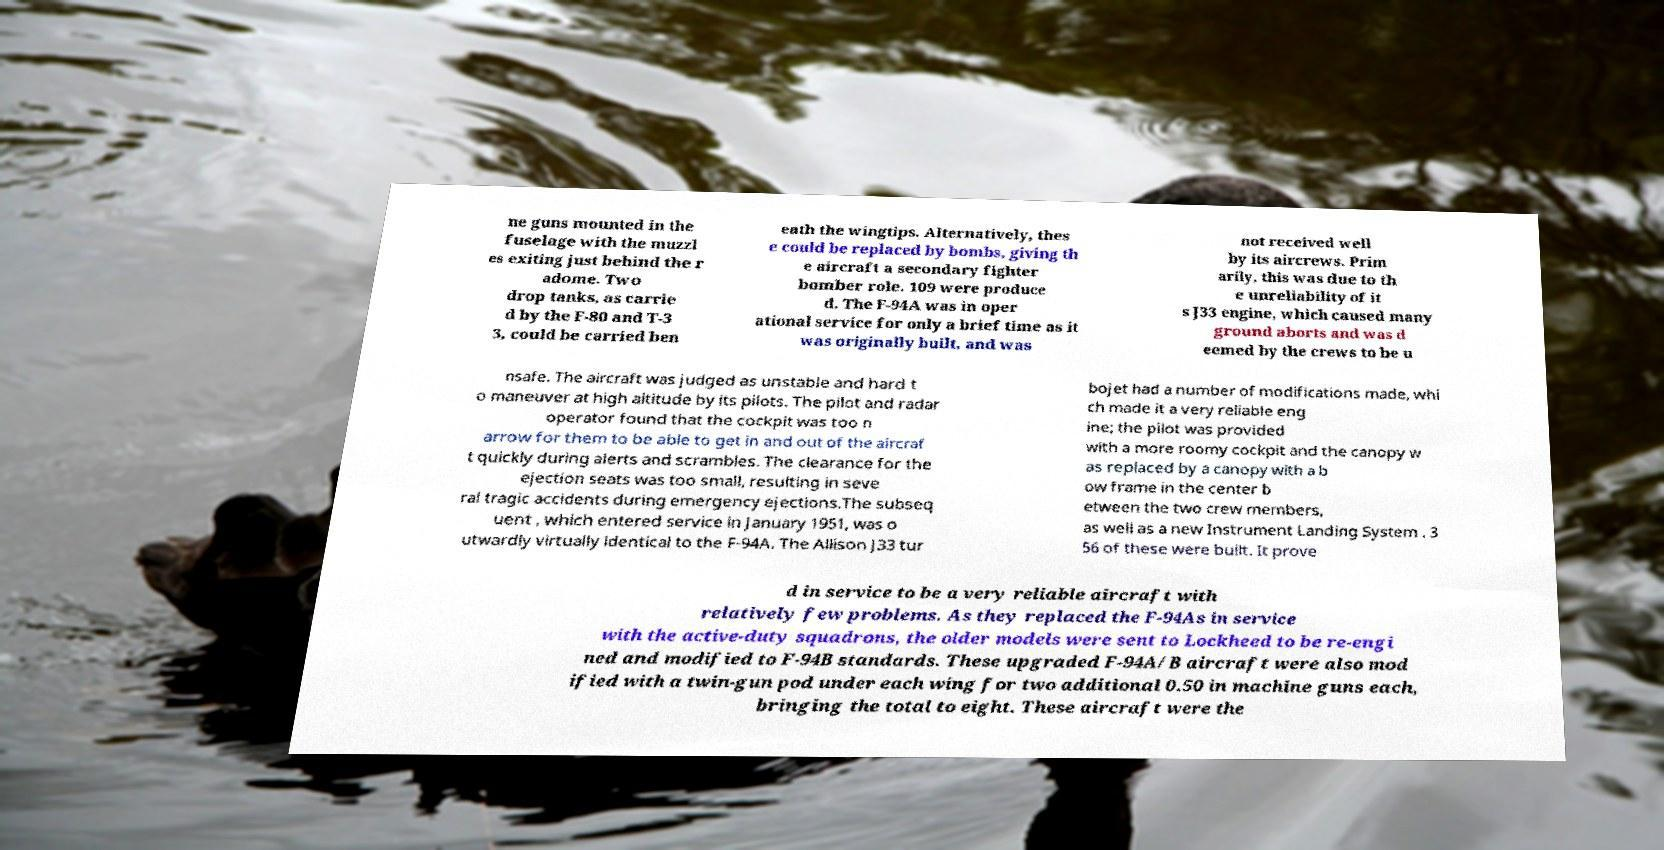Please identify and transcribe the text found in this image. ne guns mounted in the fuselage with the muzzl es exiting just behind the r adome. Two drop tanks, as carrie d by the F-80 and T-3 3, could be carried ben eath the wingtips. Alternatively, thes e could be replaced by bombs, giving th e aircraft a secondary fighter bomber role. 109 were produce d. The F-94A was in oper ational service for only a brief time as it was originally built, and was not received well by its aircrews. Prim arily, this was due to th e unreliability of it s J33 engine, which caused many ground aborts and was d eemed by the crews to be u nsafe. The aircraft was judged as unstable and hard t o maneuver at high altitude by its pilots. The pilot and radar operator found that the cockpit was too n arrow for them to be able to get in and out of the aircraf t quickly during alerts and scrambles. The clearance for the ejection seats was too small, resulting in seve ral tragic accidents during emergency ejections.The subseq uent , which entered service in January 1951, was o utwardly virtually identical to the F-94A. The Allison J33 tur bojet had a number of modifications made, whi ch made it a very reliable eng ine; the pilot was provided with a more roomy cockpit and the canopy w as replaced by a canopy with a b ow frame in the center b etween the two crew members, as well as a new Instrument Landing System . 3 56 of these were built. It prove d in service to be a very reliable aircraft with relatively few problems. As they replaced the F-94As in service with the active-duty squadrons, the older models were sent to Lockheed to be re-engi ned and modified to F-94B standards. These upgraded F-94A/B aircraft were also mod ified with a twin-gun pod under each wing for two additional 0.50 in machine guns each, bringing the total to eight. These aircraft were the 